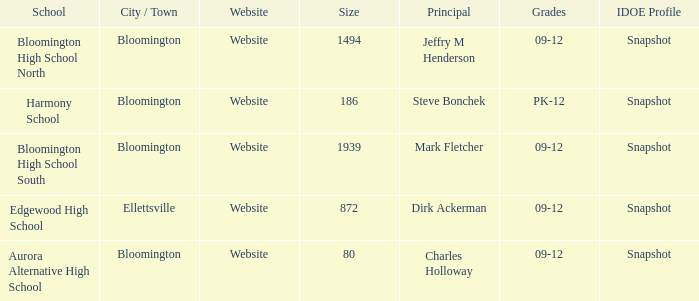Where's the school that Mark Fletcher is the principal of? Bloomington. 